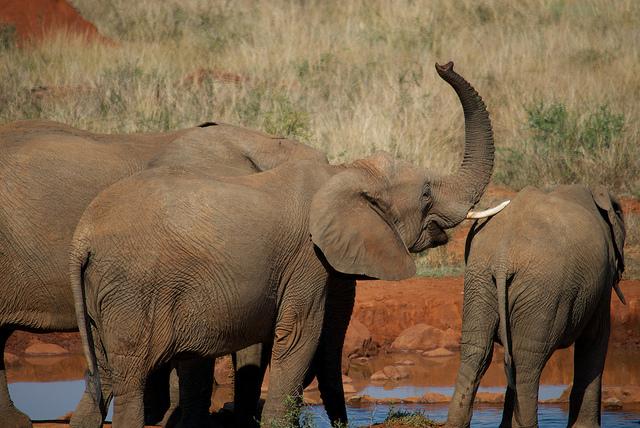What color are the animals?
Be succinct. Gray. What are elephants doing?
Keep it brief. Drinking. How many elephants are there?
Be succinct. 3. Is the elephant's tusk touching anything?
Short answer required. Yes. How many elephants are in the picture?
Answer briefly. 3. What is the middle elephant doing?
Keep it brief. Poking. 